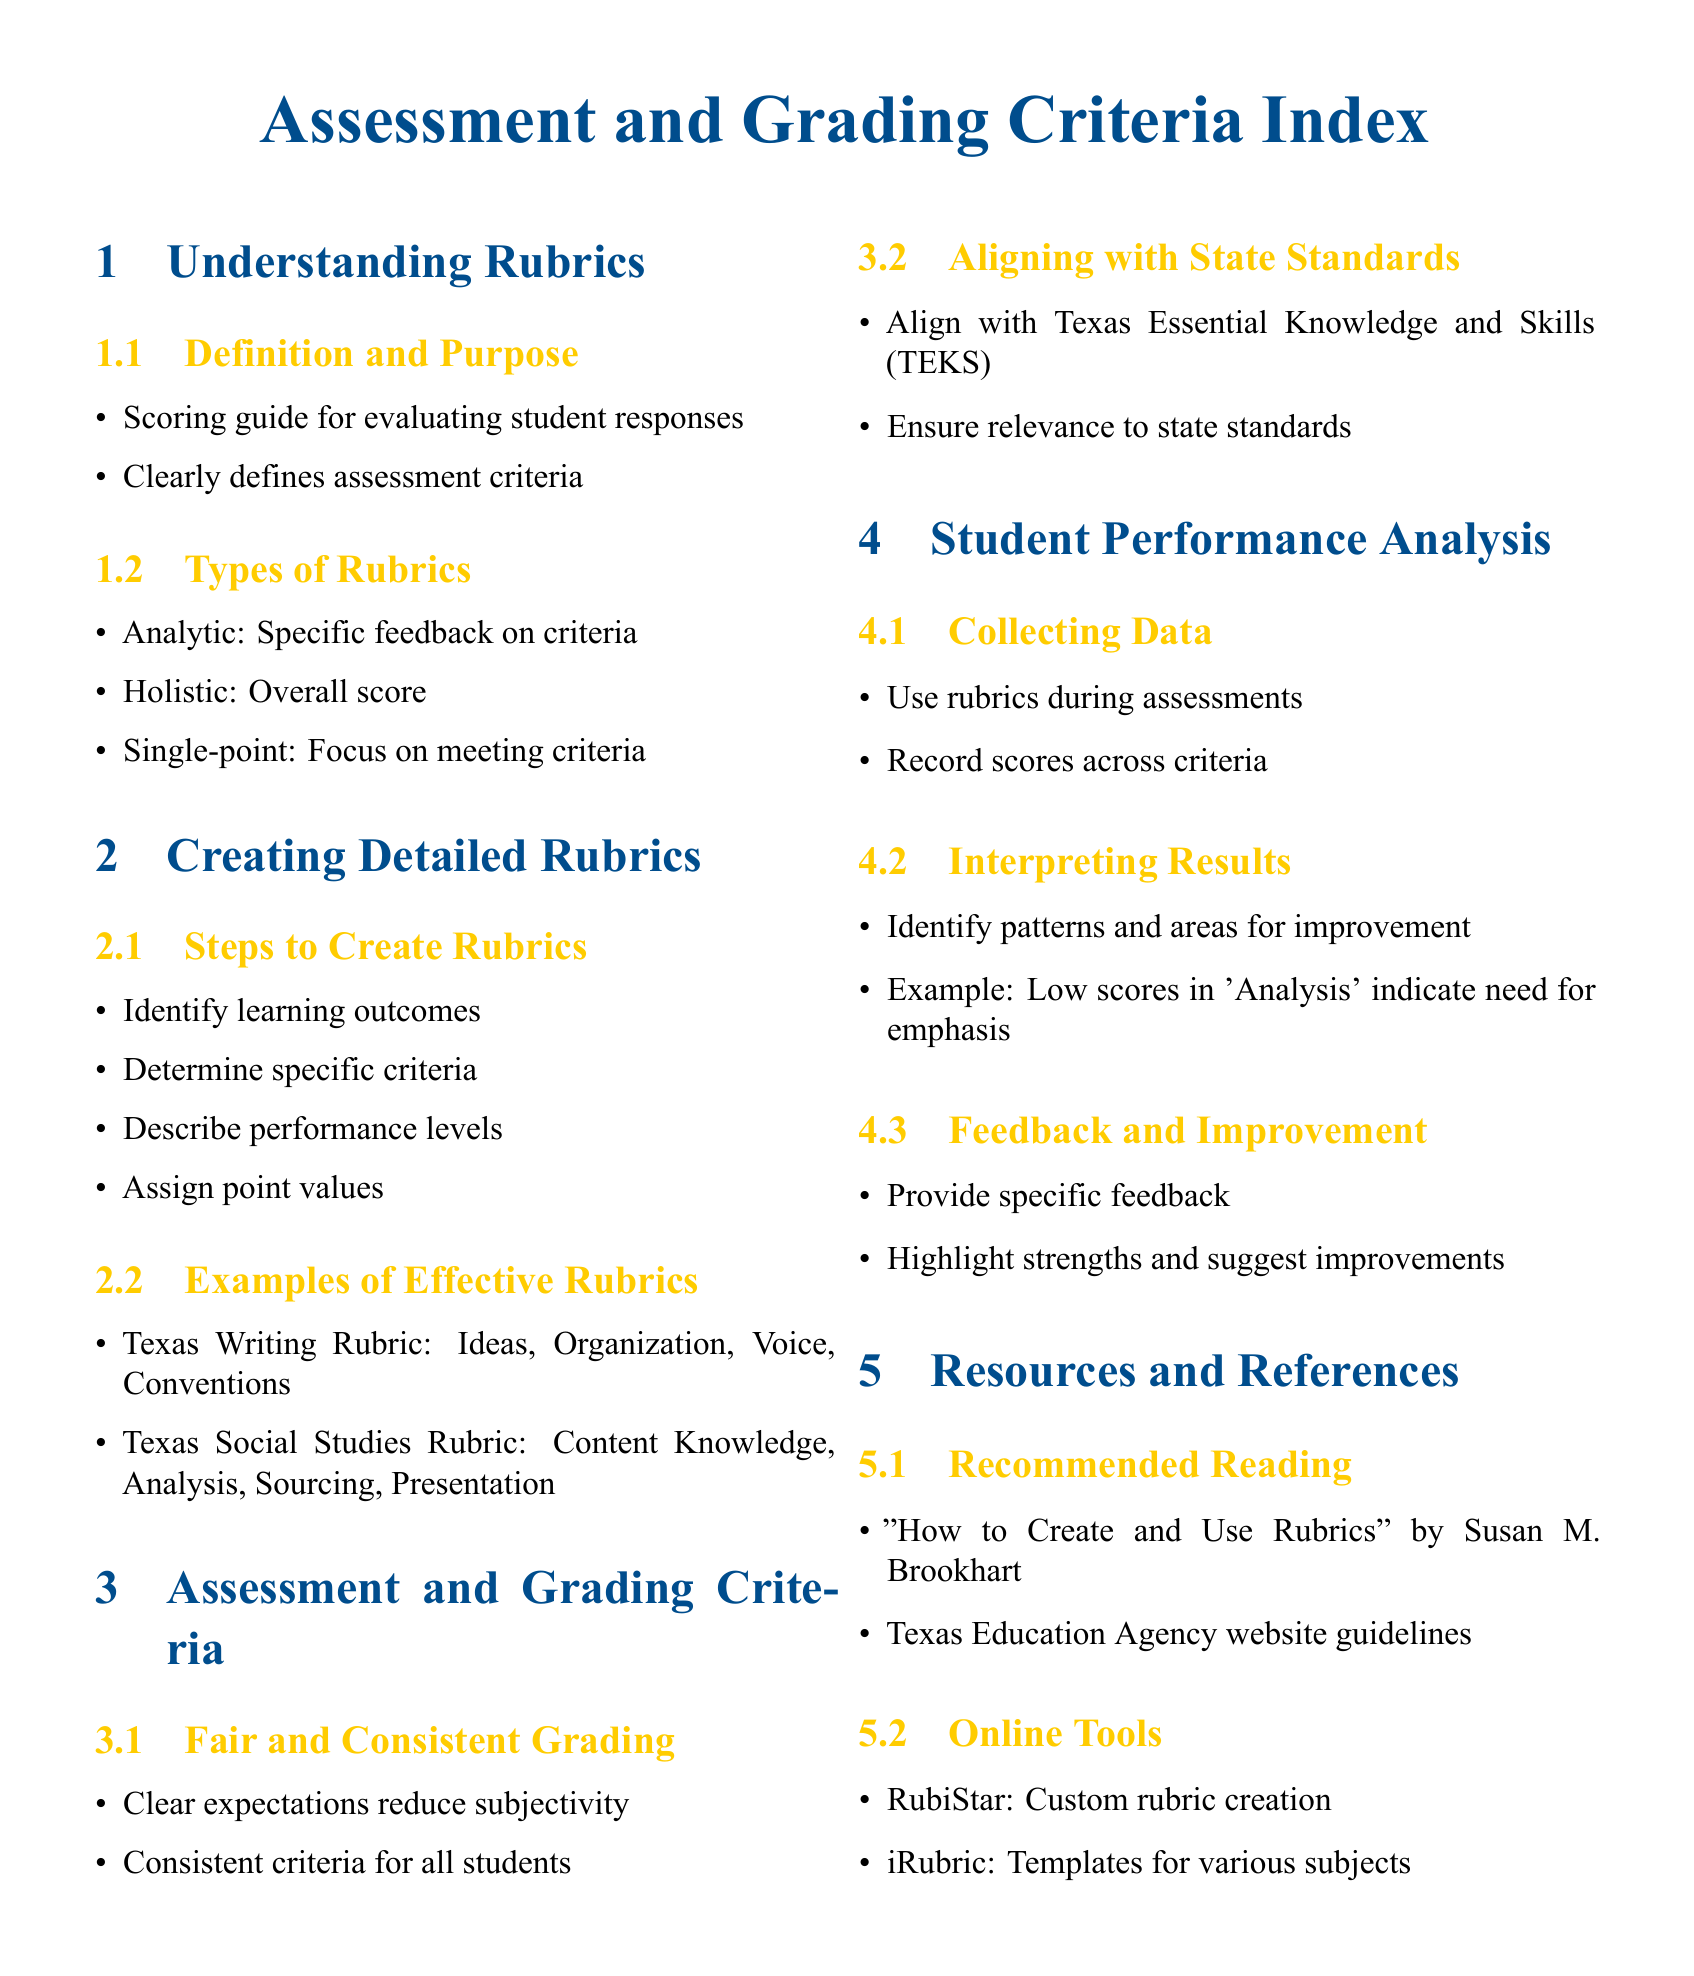What is the purpose of a rubric? A rubric serves as a scoring guide for evaluating student responses and clearly defines assessment criteria.
Answer: Scoring guide What are the types of rubrics mentioned? The document lists three types of rubrics, which are analytic, holistic, and single-point.
Answer: Analytic, holistic, single-point What is the Texas Writing Rubric focused on? The Texas Writing Rubric includes four criteria: ideas, organization, voice, and conventions.
Answer: Ideas, organization, voice, conventions What is one way to ensure fair grading? Clear expectations reduce subjectivity, allowing for consistent criteria for all students.
Answer: Clear expectations What tool is recommended for custom rubric creation? The document mentions RubiStar as an online tool for creating custom rubrics.
Answer: RubiStar How many steps are there to create rubrics according to the document? The document outlines four steps involved in creating rubrics.
Answer: Four What should be aligned with state standards? Assessment criteria should be aligned with the Texas Essential Knowledge and Skills, or TEKS.
Answer: TEKS What is emphasized in student performance analysis? The analysis involves collecting data, interpreting results, and providing feedback for improvement.
Answer: Feedback and improvement What is one example of a recommended reading? The document suggests "How to Create and Use Rubrics" by Susan M. Brookhart as recommended reading.
Answer: Susan M. Brookhart 